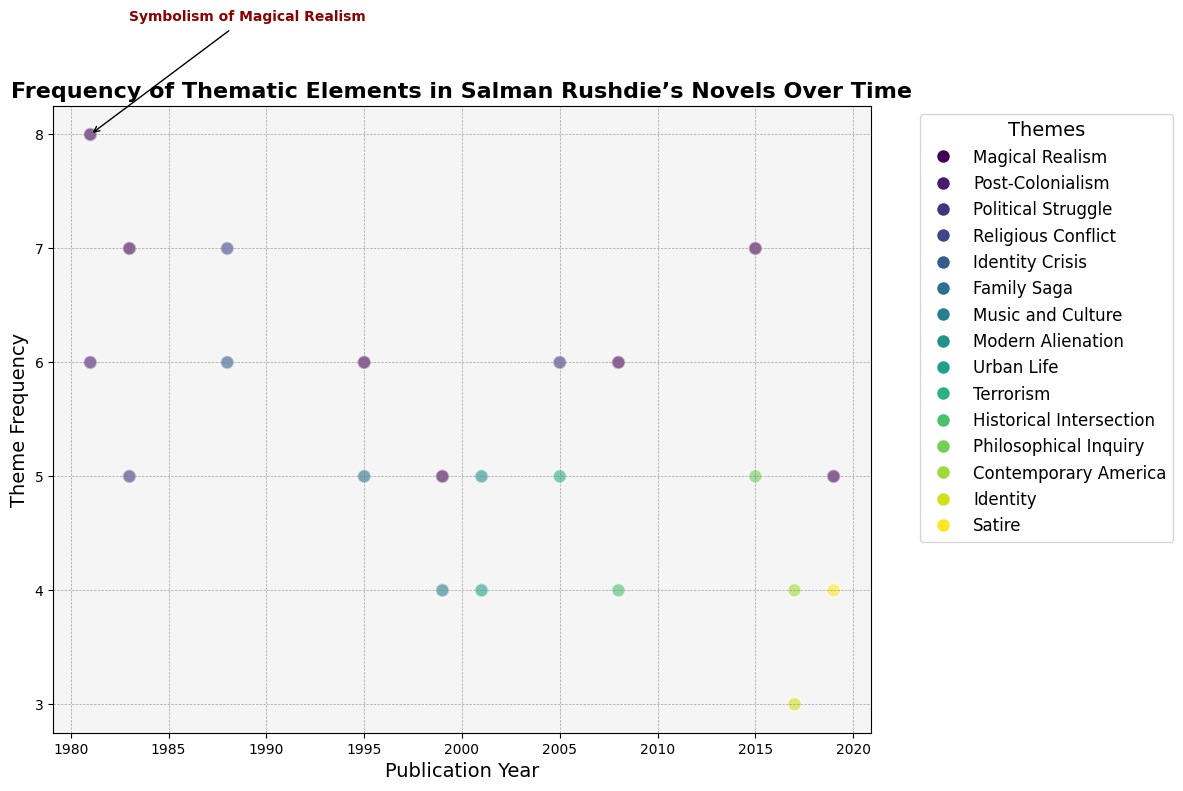How many novels with a theme of Political Struggle were published before the year 2000, and what is the sum of their theme frequencies? There are two novels with the theme of Political Struggle published before 2000: "Shame" (1983) and "Shalimar the Clown" (2005 is after 2000). By considering the theme frequency of "Shame" which is 5, the sum of their theme frequencies is 5.
Answer: 5 How does the frequency of Magical Realism in "Midnight's Children" compare to the frequency of Magical Realism in "Quichotte"? The frequency of Magical Realism in "Midnight's Children" (1981) is 8, while in "Quichotte" (2019), the frequency is 5. Comparing these, "Midnight's Children" has a higher frequency.
Answer: "Midnight's Children" > "Quichotte" Which novel released after 2000 has the highest theme frequency, and what theme does it represent? "Shalimar the Clown" (2005) with a theme frequency of 6 in Political Struggle is one of the highest after 2000. The other novel released after 2000 with the highest frequency for a different theme is "Two Years Eight Months and Twenty-Eight Nights" (2015) with a frequency of 7 for Magical Realism. Therefore, the highest theme frequency after 2000 is 7 in "Two Years Eight Months and Twenty-Eight Nights", representing Magical Realism.
Answer: "Two Years Eight Months and Twenty-Eight Nights", Magical Realism What is the difference between the highest and lowest theme frequencies among all novels? The highest theme frequency is 8 ("Midnight's Children" - Magical Realism), and the lowest theme frequency is 3 ("The Golden House" - Identity). The difference between them is 8 - 3 = 5.
Answer: 5 From the annotation visible in the scatter plot, what thematic element in "Midnight's Children" is highlighted, and what year is it associated with? The annotation on the scatter plot highlights the symbolism of Magical Realism in "Midnight's Children", which is associated with the publication year of 1981.
Answer: Magical Realism, 1981 Which theme appears most frequently across all novels, and what is its total count? The theme of Magical Realism appears most frequently. Summing its occurrences in the novels: 8 ("Midnight's Children") + 7 ("Shame") + 6 ("The Moor's Last Sigh") + 5 ("The Ground Beneath Her Feet") + 6 ("The Enchantress of Florence") + 7 ("Two Years Eight Months and Twenty-Eight Nights") + 5 ("Quichotte") = 44.
Answer: Magical Realism, 44 Which themes are represented in both "Shame" and "Shalimar the Clown", and how do their frequencies compare within each novel? The theme represented in both "Shame" (1983) and "Shalimar the Clown" (2005) is Political Struggle. The frequency of Political Struggle in "Shame" is 5, and in "Shalimar the Clown" it is 6, so "Shalimar the Clown" has a higher frequency for this theme.
Answer: Political Struggle; "Shame" = 5, "Shalimar the Clown" = 6 